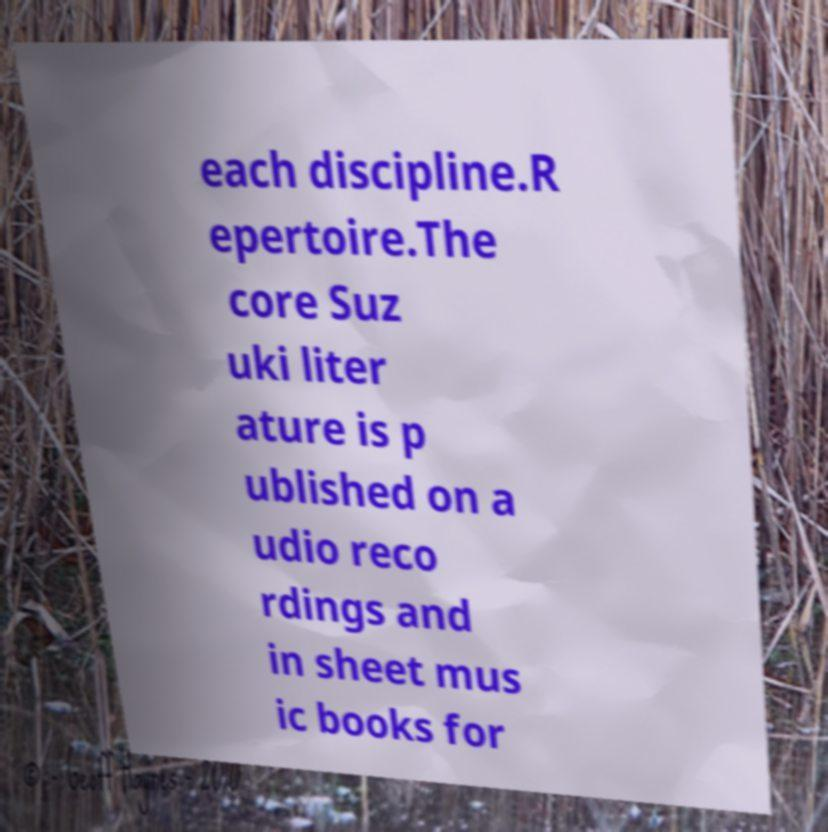For documentation purposes, I need the text within this image transcribed. Could you provide that? each discipline.R epertoire.The core Suz uki liter ature is p ublished on a udio reco rdings and in sheet mus ic books for 